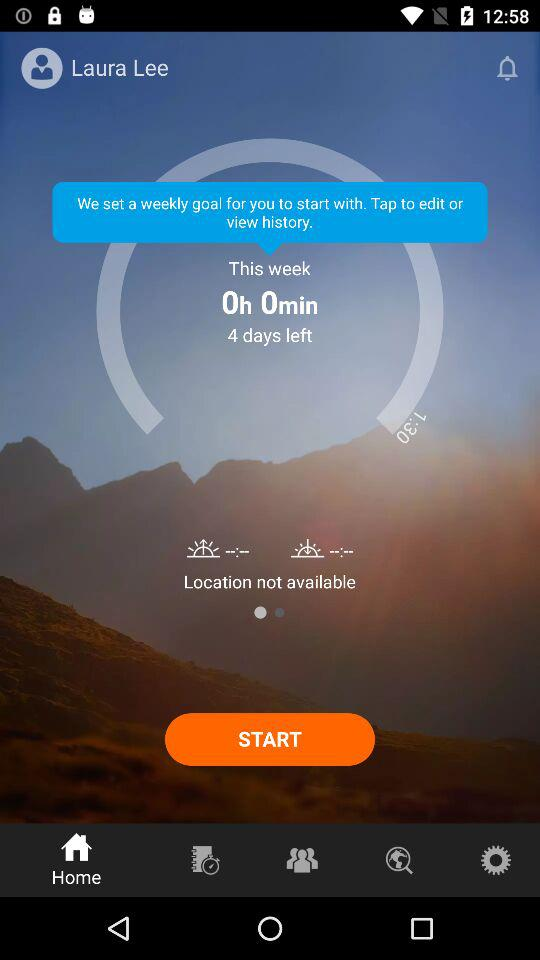How many days are left? There are 4 days left. 